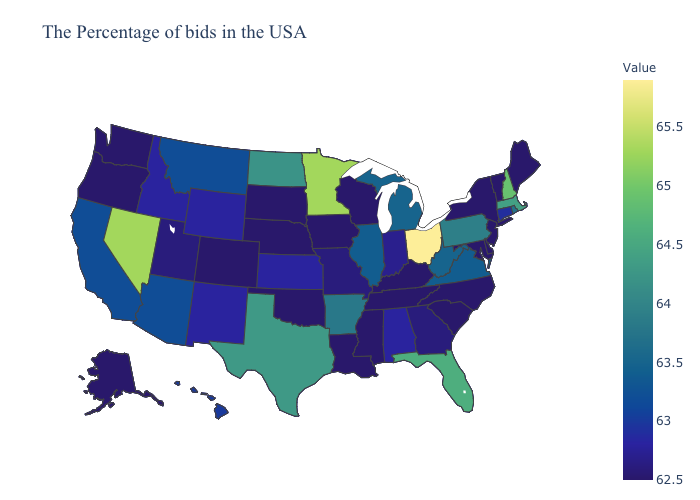Does the map have missing data?
Short answer required. No. Does Colorado have a lower value than Virginia?
Give a very brief answer. Yes. Among the states that border Utah , which have the lowest value?
Write a very short answer. Colorado. 